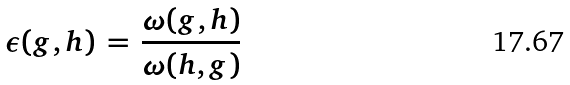Convert formula to latex. <formula><loc_0><loc_0><loc_500><loc_500>\epsilon ( g , h ) \, = \, \frac { \omega ( g , h ) } { \omega ( h , g ) }</formula> 